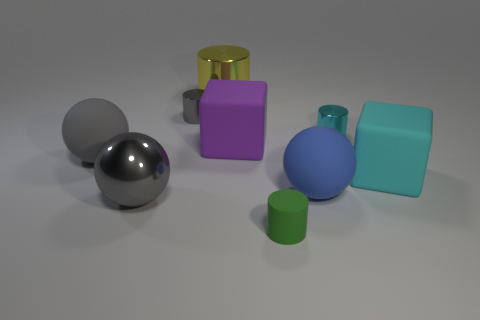Subtract all large rubber spheres. How many spheres are left? 1 Subtract all brown blocks. How many gray spheres are left? 2 Subtract all yellow cylinders. How many cylinders are left? 3 Subtract all cylinders. How many objects are left? 5 Subtract all yellow spheres. Subtract all yellow cubes. How many spheres are left? 3 Add 4 big gray spheres. How many big gray spheres exist? 6 Subtract 1 green cylinders. How many objects are left? 8 Subtract all gray cylinders. Subtract all cylinders. How many objects are left? 4 Add 5 tiny cyan things. How many tiny cyan things are left? 6 